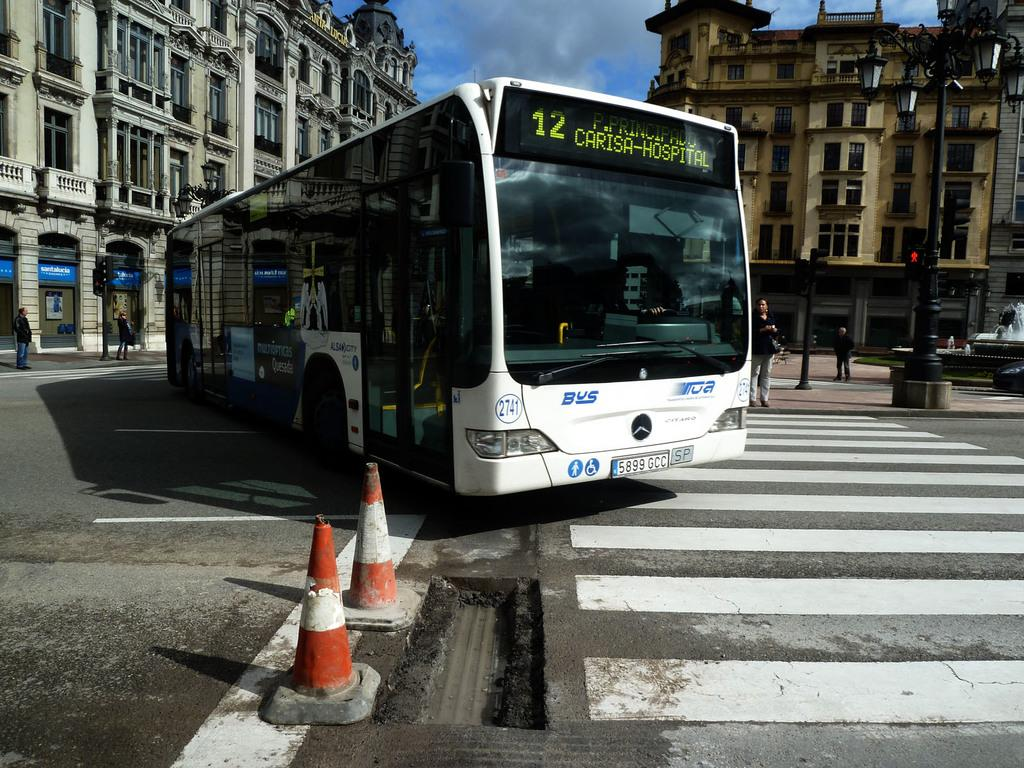Provide a one-sentence caption for the provided image. The number 12 bus coming down a street in part of a old city. 